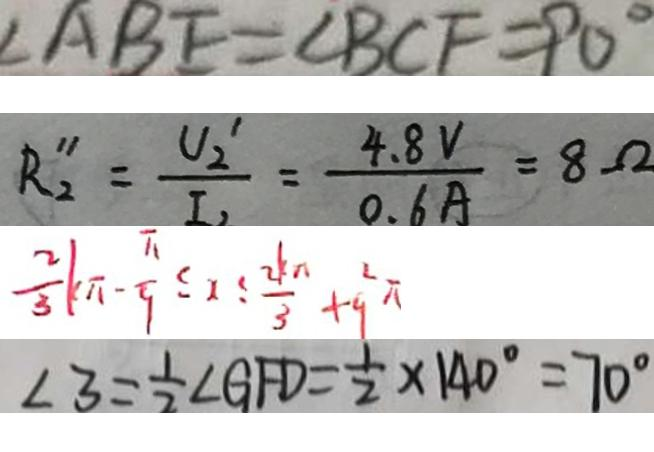<formula> <loc_0><loc_0><loc_500><loc_500>\angle A B E = \angle B C F = 9 0 ^ { \circ } 
 R _ { 2 } ^ { \prime \prime } = \frac { U _ { 2 } ^ { \prime } } { I _ { 2 } } = \frac { 4 . 8 V } { 0 . 6 A } = 8 \Omega 
 \frac { 2 } { 3 } k \pi - \frac { \pi } { 9 } \leq 1 \leq \frac { 2 k \pi } { 3 } + 9 ^ { 2 } \pi 
 \angle 3 = \frac { 1 } { 2 } \angle G F D = \frac { 1 } { 2 } \times 1 4 0 ^ { \circ } = 7 0 ^ { \circ }</formula> 